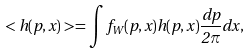<formula> <loc_0><loc_0><loc_500><loc_500>< h ( p , x ) > = \int f _ { W } ( p , x ) h ( p , x ) \frac { d p } { 2 \pi } d x ,</formula> 